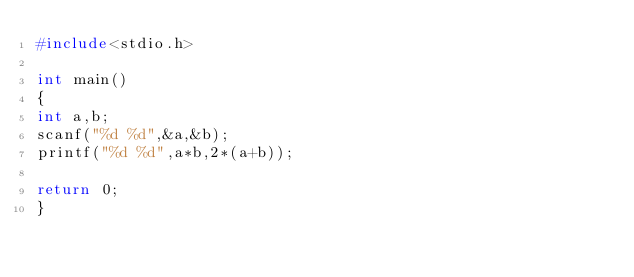<code> <loc_0><loc_0><loc_500><loc_500><_C_>#include<stdio.h>

int main()
{
int a,b;
scanf("%d %d",&a,&b);
printf("%d %d",a*b,2*(a+b));

return 0;
}</code> 